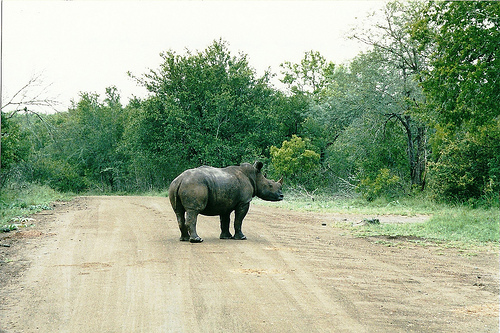<image>
Is there a rhino in front of the plants? Yes. The rhino is positioned in front of the plants, appearing closer to the camera viewpoint. 